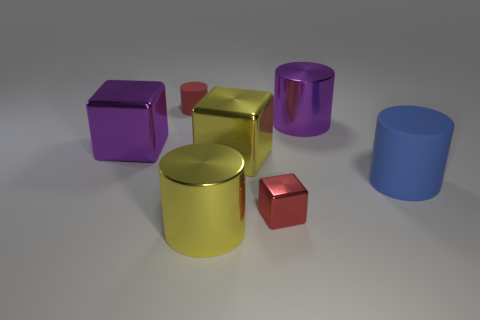Add 1 matte cylinders. How many objects exist? 8 Subtract all cylinders. How many objects are left? 3 Subtract all large blocks. Subtract all tiny red rubber cylinders. How many objects are left? 4 Add 3 small red objects. How many small red objects are left? 5 Add 7 big purple objects. How many big purple objects exist? 9 Subtract 0 purple balls. How many objects are left? 7 